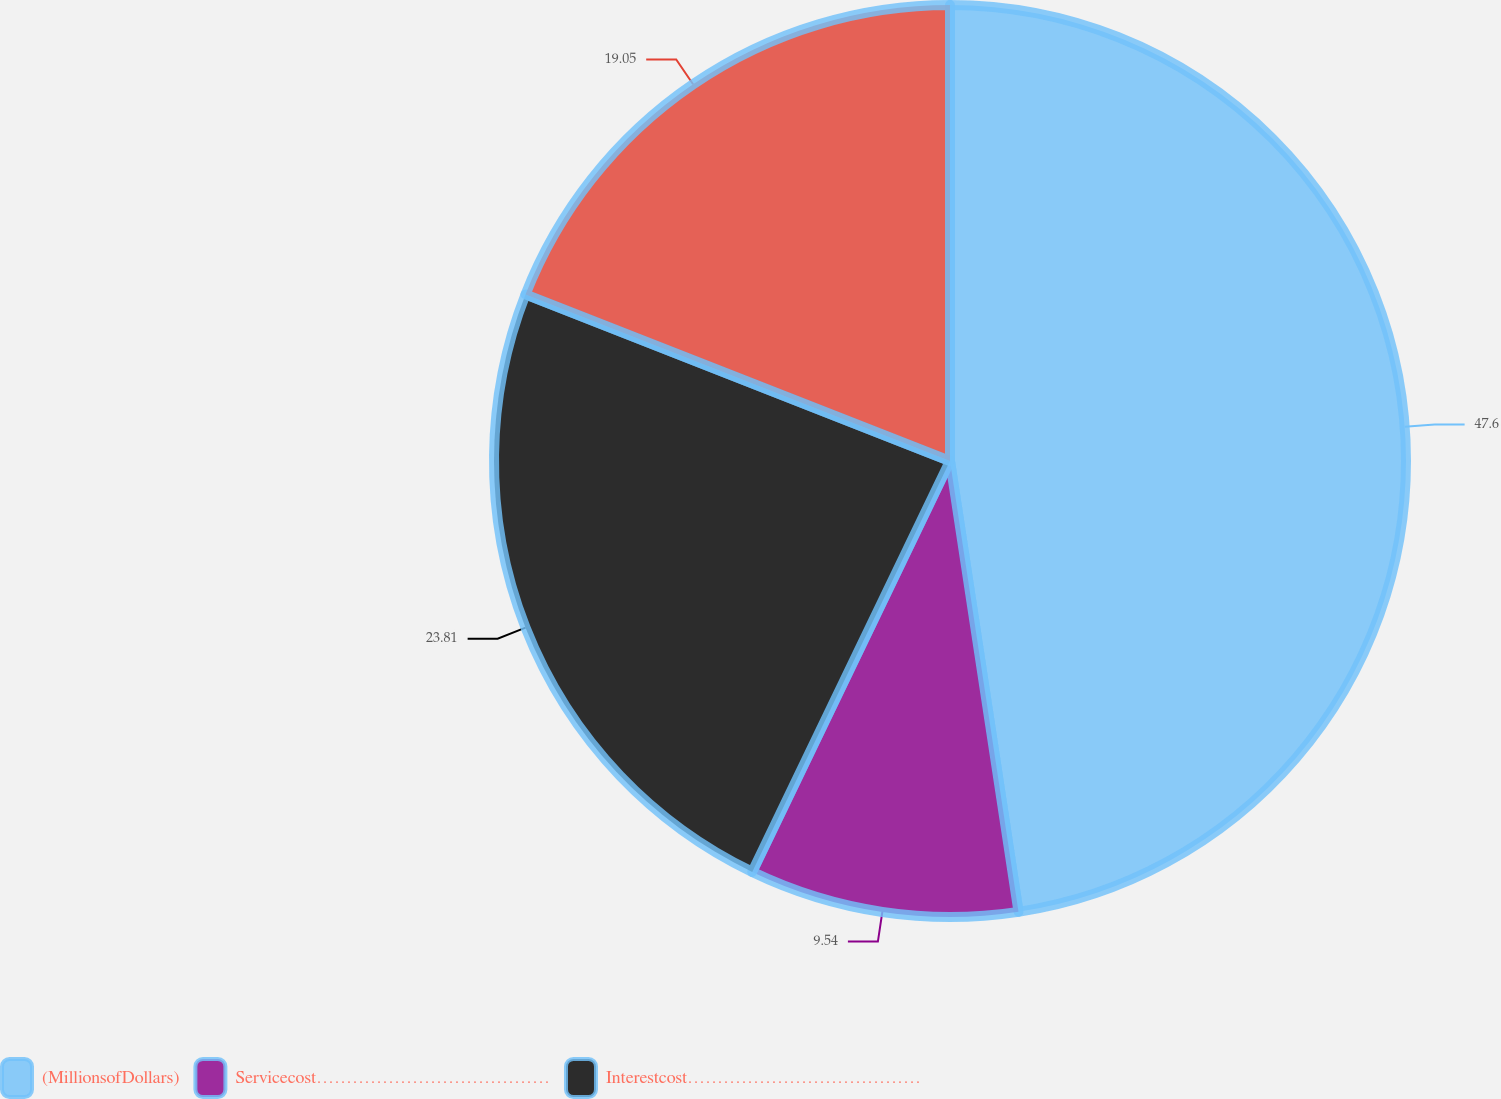<chart> <loc_0><loc_0><loc_500><loc_500><pie_chart><fcel>(MillionsofDollars)<fcel>Servicecost…………………………………<fcel>Interestcost…………………………………<fcel>Unnamed: 3<nl><fcel>47.6%<fcel>9.54%<fcel>23.81%<fcel>19.05%<nl></chart> 